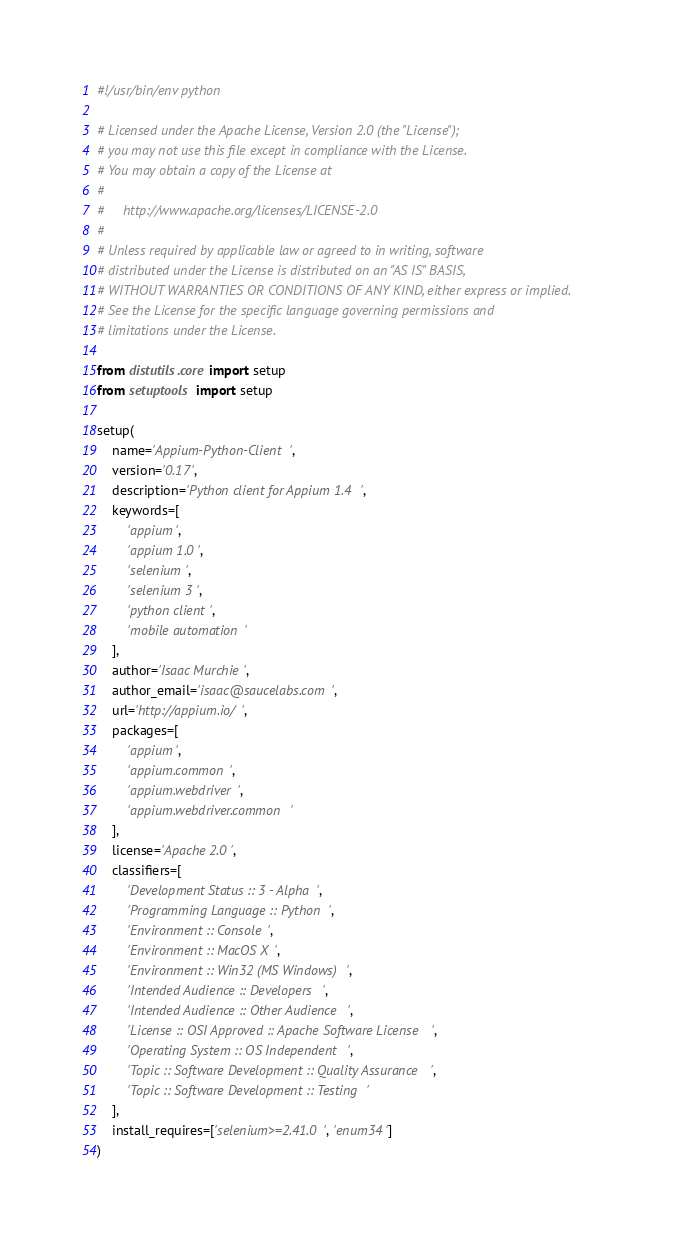Convert code to text. <code><loc_0><loc_0><loc_500><loc_500><_Python_>#!/usr/bin/env python

# Licensed under the Apache License, Version 2.0 (the "License");
# you may not use this file except in compliance with the License.
# You may obtain a copy of the License at
#
#     http://www.apache.org/licenses/LICENSE-2.0
#
# Unless required by applicable law or agreed to in writing, software
# distributed under the License is distributed on an "AS IS" BASIS,
# WITHOUT WARRANTIES OR CONDITIONS OF ANY KIND, either express or implied.
# See the License for the specific language governing permissions and
# limitations under the License.

from distutils.core import setup
from setuptools import setup

setup(
    name='Appium-Python-Client',
    version='0.17',
    description='Python client for Appium 1.4',
    keywords=[
        'appium',
        'appium 1.0',
        'selenium',
        'selenium 3',
        'python client',
        'mobile automation'
    ],
    author='Isaac Murchie',
    author_email='isaac@saucelabs.com',
    url='http://appium.io/',
    packages=[
        'appium',
        'appium.common',
        'appium.webdriver',
        'appium.webdriver.common'
    ],
    license='Apache 2.0',
    classifiers=[
        'Development Status :: 3 - Alpha',
        'Programming Language :: Python',
        'Environment :: Console',
        'Environment :: MacOS X',
        'Environment :: Win32 (MS Windows)',
        'Intended Audience :: Developers',
        'Intended Audience :: Other Audience',
        'License :: OSI Approved :: Apache Software License',
        'Operating System :: OS Independent',
        'Topic :: Software Development :: Quality Assurance',
        'Topic :: Software Development :: Testing'
    ],
    install_requires=['selenium>=2.41.0', 'enum34']
)
</code> 